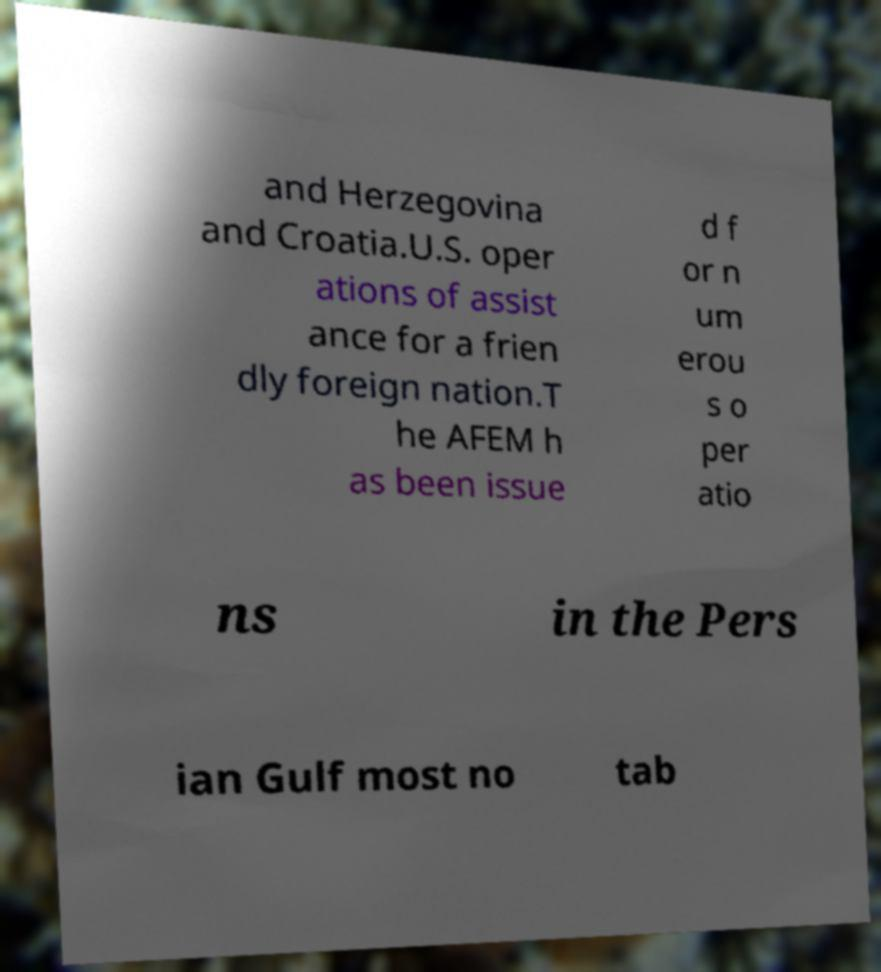Please read and relay the text visible in this image. What does it say? and Herzegovina and Croatia.U.S. oper ations of assist ance for a frien dly foreign nation.T he AFEM h as been issue d f or n um erou s o per atio ns in the Pers ian Gulf most no tab 